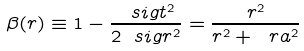Convert formula to latex. <formula><loc_0><loc_0><loc_500><loc_500>\beta ( r ) \equiv 1 - \frac { \ s i g t ^ { 2 } } { 2 \ s i g r ^ { 2 } } = \frac { r ^ { 2 } } { r ^ { 2 } + \ r a ^ { 2 } }</formula> 